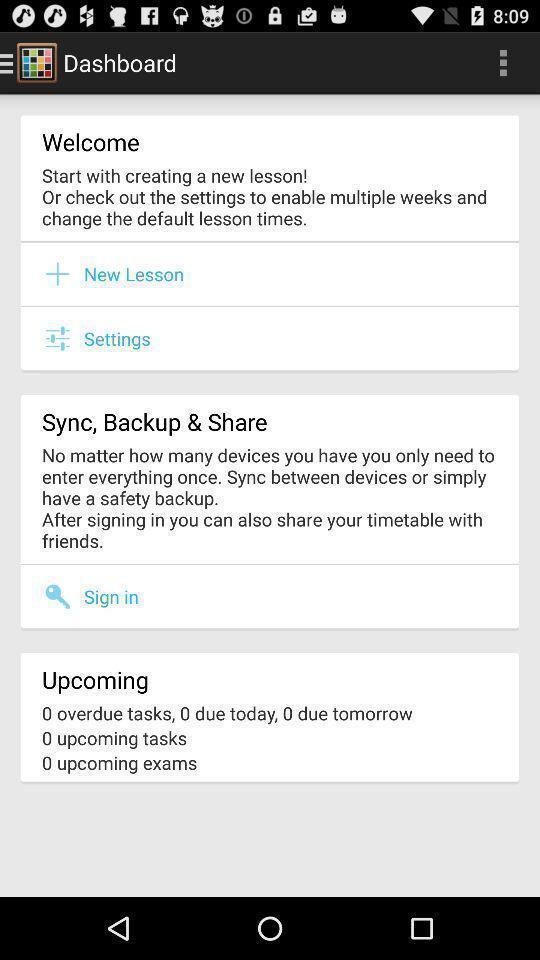Summarize the main components in this picture. Welcoming page of a dashboard. 